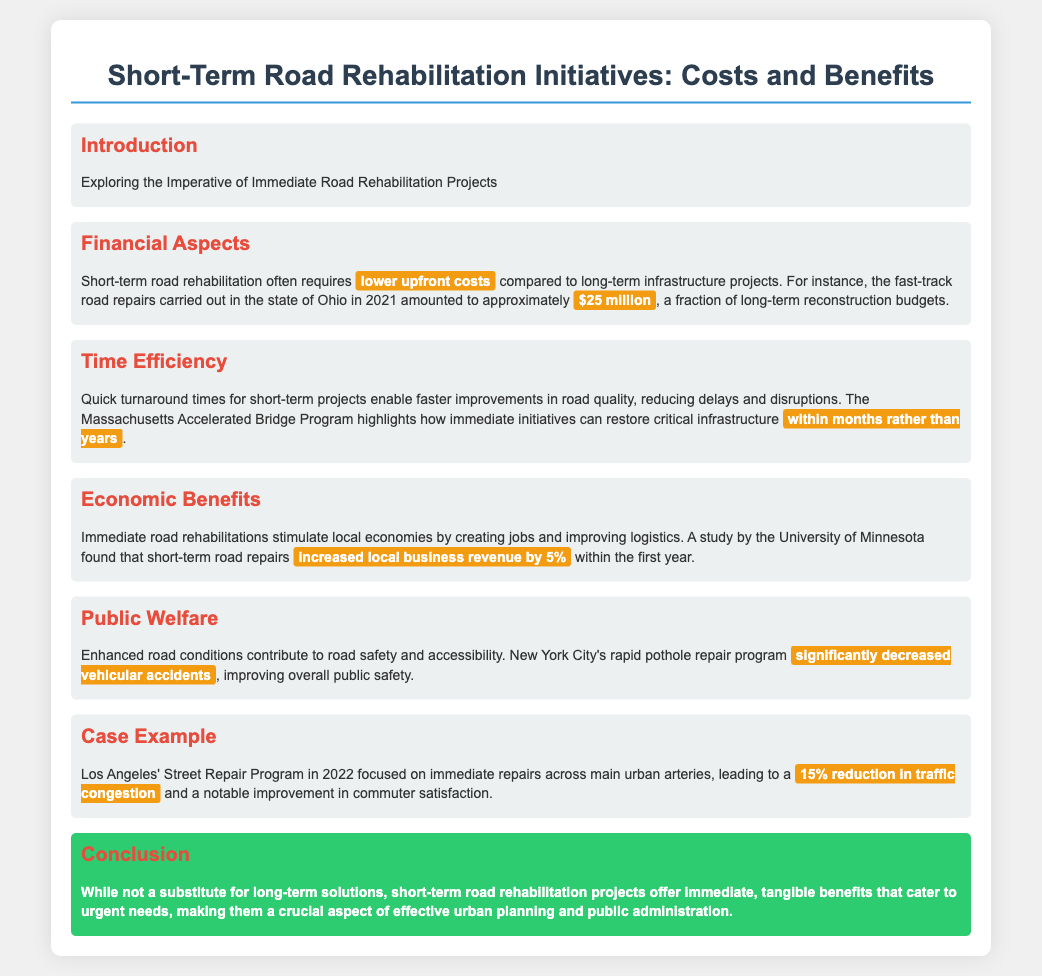what was the cost of the road repairs in Ohio in 2021? The document states that the fast-track road repairs in Ohio in 2021 amounted to approximately $25 million.
Answer: $25 million what is a significant benefit of short-term road rehabilitation regarding project duration? The document mentions that immediate initiatives can restore critical infrastructure within months rather than years.
Answer: within months rather than years how much did local business revenue increase as reported by the University of Minnesota? The document highlights that short-term road repairs increased local business revenue by 5% within the first year.
Answer: 5% what program significantly decreased vehicular accidents in New York City? The document refers to New York City's rapid pothole repair program as having significantly decreased vehicular accidents.
Answer: rapid pothole repair program what percentage reduction in traffic congestion was achieved by Los Angeles' Street Repair Program? The document indicates that the program led to a 15% reduction in traffic congestion.
Answer: 15% what do short-term road rehabilitation projects offer according to the conclusion? The conclusion states that these projects offer immediate, tangible benefits that cater to urgent needs.
Answer: immediate, tangible benefits what role do immediate road rehabilitations play in local economies? The document states that they stimulate local economies by creating jobs and improving logistics.
Answer: creating jobs and improving logistics what is the impact of short-term road rehabilitation on public welfare? Enhanced road conditions contribute to road safety and accessibility, improving overall public safety.
Answer: improve overall public safety 